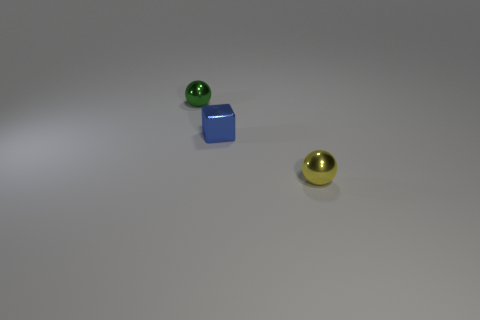What number of other things are there of the same shape as the small yellow thing?
Provide a succinct answer. 1. What number of cubes are left of the small yellow metallic ball?
Make the answer very short. 1. Are there fewer tiny green things in front of the small blue metal block than metallic spheres that are left of the tiny yellow thing?
Offer a very short reply. Yes. What shape is the tiny yellow shiny thing to the right of the sphere that is behind the tiny metallic object to the right of the blue block?
Keep it short and to the point. Sphere. There is a tiny metallic thing that is both behind the yellow metallic sphere and right of the tiny green metallic thing; what is its shape?
Ensure brevity in your answer.  Cube. Are there any big green things made of the same material as the tiny block?
Offer a terse response. No. There is a ball in front of the small green shiny ball; what is its color?
Give a very brief answer. Yellow. There is a tiny green thing; does it have the same shape as the thing that is on the right side of the blue object?
Your answer should be compact. Yes. The green thing that is made of the same material as the small yellow object is what size?
Your answer should be very brief. Small. There is a object on the left side of the blue object; does it have the same shape as the yellow object?
Make the answer very short. Yes. 